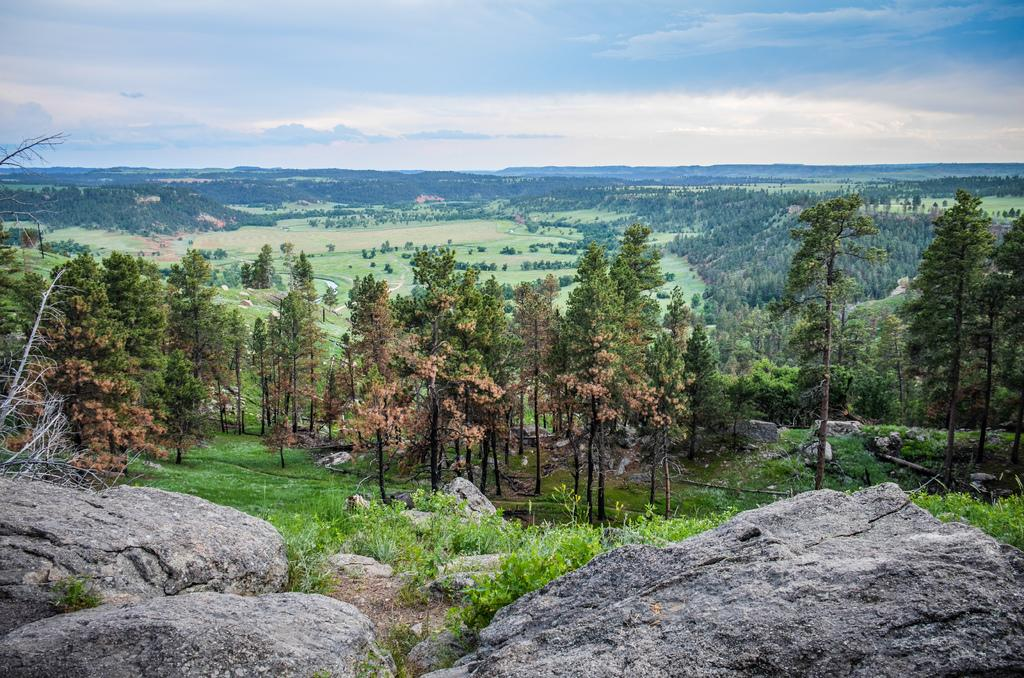What type of natural elements can be seen in the image? There are rocks and grass in the image. What can be seen in the background of the image? There are many trees and clouds in the background of the image. What part of the natural environment is visible in the sky visible in the image? The sky is visible in the background of the image. What type of weather can be seen in the image? The image does not depict any specific weather conditions; it only shows rocks, grass, trees, clouds, and the sky. 